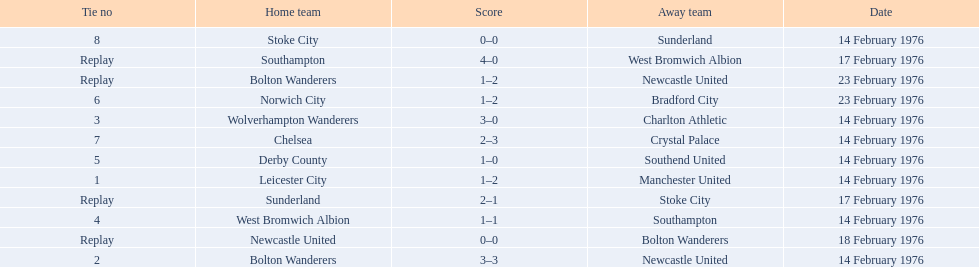What were the home teams in the 1975-76 fa cup? Leicester City, Bolton Wanderers, Newcastle United, Bolton Wanderers, Wolverhampton Wanderers, West Bromwich Albion, Southampton, Derby County, Norwich City, Chelsea, Stoke City, Sunderland. Which of these teams had the tie number 1? Leicester City. 